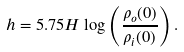<formula> <loc_0><loc_0><loc_500><loc_500>h = 5 . 7 5 H \log \left ( \frac { \rho _ { o } ( 0 ) } { \rho _ { i } ( 0 ) } \right ) .</formula> 